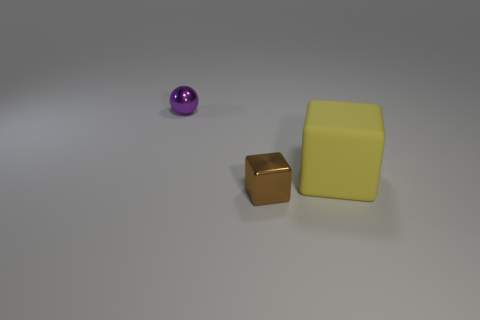Are there any other things that are made of the same material as the brown object?
Provide a short and direct response. Yes. How many blue things are there?
Offer a very short reply. 0. Do the shiny ball and the big object have the same color?
Offer a terse response. No. There is a object that is both on the right side of the sphere and behind the small brown object; what color is it?
Offer a terse response. Yellow. There is a big rubber object; are there any yellow rubber cubes on the right side of it?
Provide a short and direct response. No. What number of small brown metal cubes are left of the block that is left of the yellow block?
Offer a very short reply. 0. What is the size of the thing that is the same material as the small ball?
Your answer should be compact. Small. The yellow matte object is what size?
Ensure brevity in your answer.  Large. Are the large yellow object and the brown cube made of the same material?
Ensure brevity in your answer.  No. How many balls are small gray objects or tiny things?
Give a very brief answer. 1. 